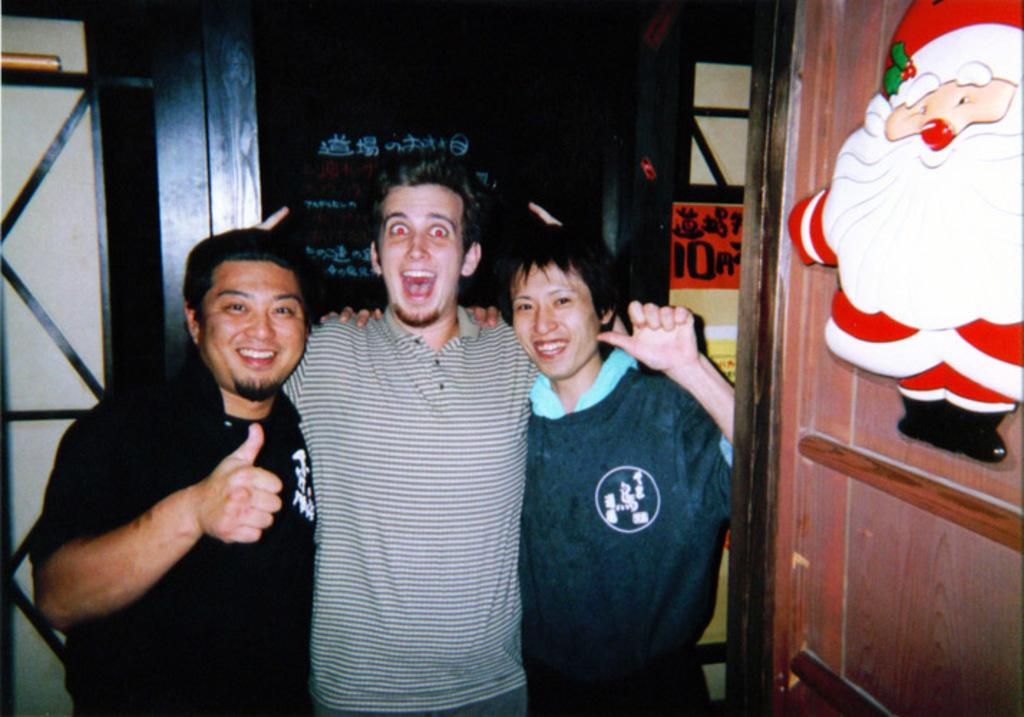How many people are in the image? There are three people in the image: two men and a woman. What are the people in the image doing? The people are standing and smiling. What can be seen in the background of the image? There are posters in the background of the image. What type of pies are being baked by the woman in the image? There is no indication in the image that anyone is baking pies, and the woman is not holding any pies or baking equipment. 